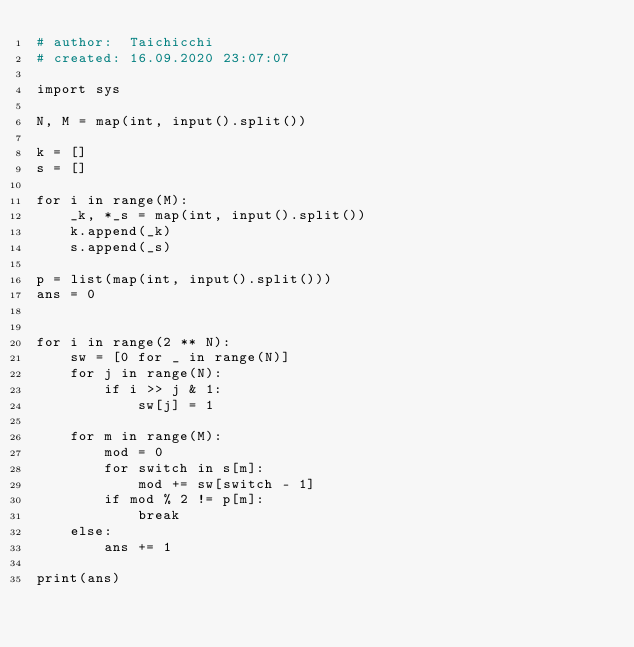<code> <loc_0><loc_0><loc_500><loc_500><_Python_># author:  Taichicchi
# created: 16.09.2020 23:07:07

import sys

N, M = map(int, input().split())

k = []
s = []

for i in range(M):
    _k, *_s = map(int, input().split())
    k.append(_k)
    s.append(_s)

p = list(map(int, input().split()))
ans = 0


for i in range(2 ** N):
    sw = [0 for _ in range(N)]
    for j in range(N):
        if i >> j & 1:
            sw[j] = 1

    for m in range(M):
        mod = 0
        for switch in s[m]:
            mod += sw[switch - 1]
        if mod % 2 != p[m]:
            break
    else:
        ans += 1

print(ans)
</code> 